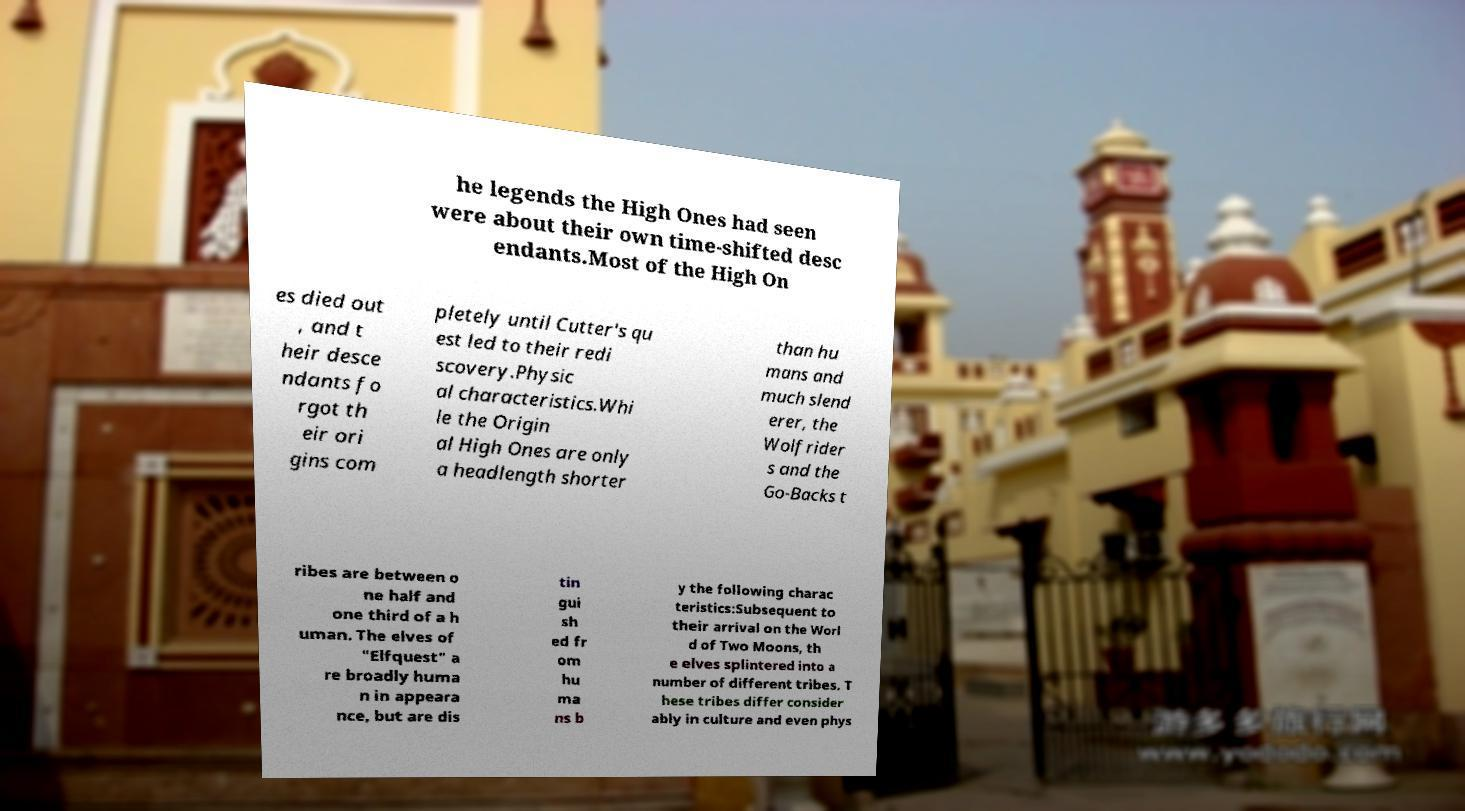Could you extract and type out the text from this image? he legends the High Ones had seen were about their own time-shifted desc endants.Most of the High On es died out , and t heir desce ndants fo rgot th eir ori gins com pletely until Cutter's qu est led to their redi scovery.Physic al characteristics.Whi le the Origin al High Ones are only a headlength shorter than hu mans and much slend erer, the Wolfrider s and the Go-Backs t ribes are between o ne half and one third of a h uman. The elves of "Elfquest" a re broadly huma n in appeara nce, but are dis tin gui sh ed fr om hu ma ns b y the following charac teristics:Subsequent to their arrival on the Worl d of Two Moons, th e elves splintered into a number of different tribes. T hese tribes differ consider ably in culture and even phys 